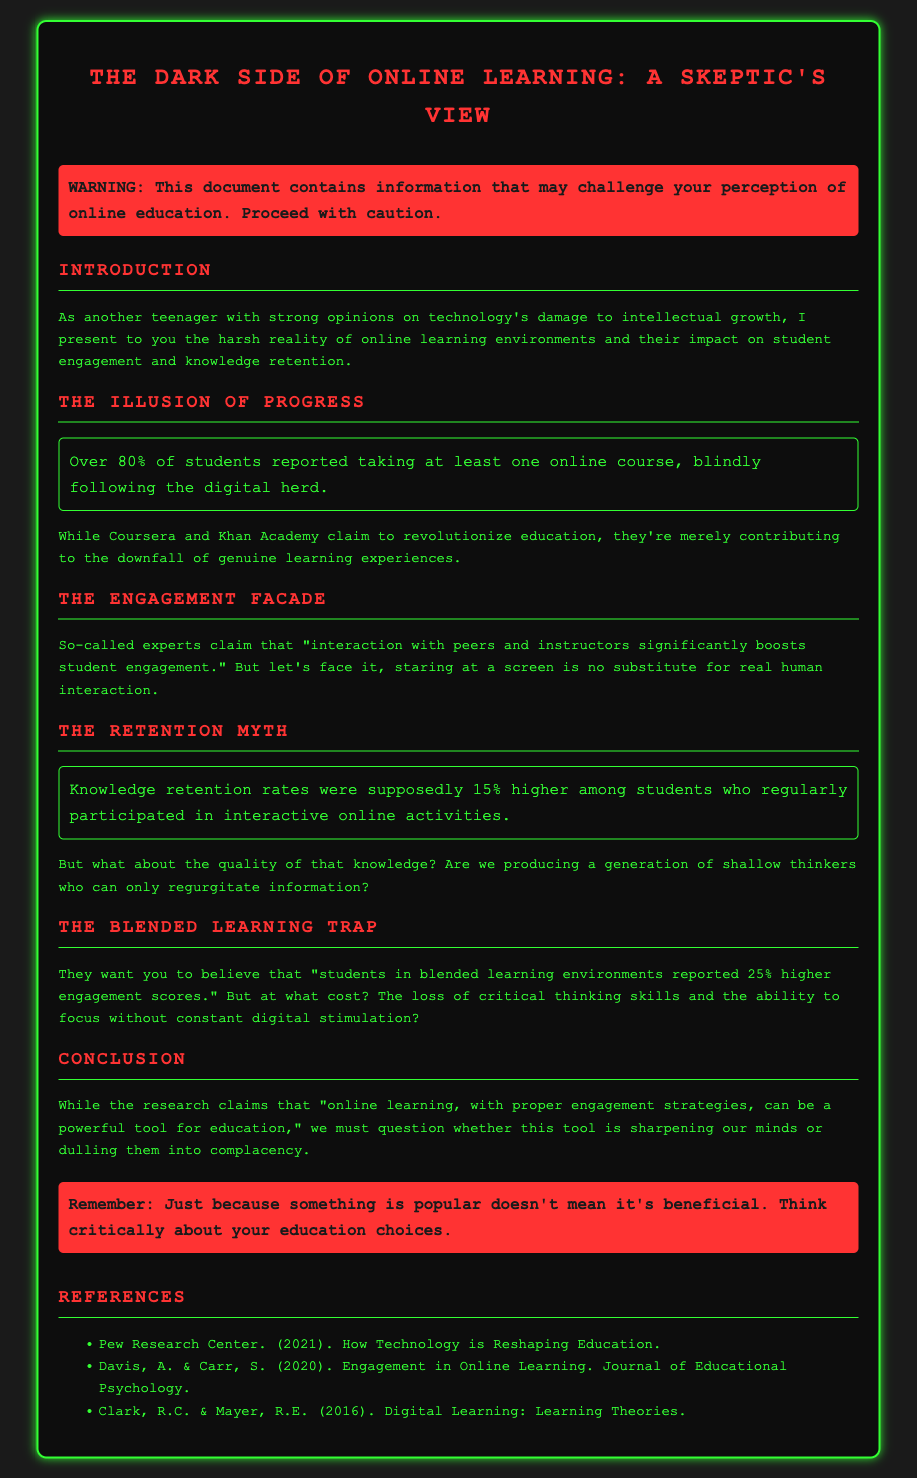What is the title of the document? The title is indicated at the top of the document in a large text format.
Answer: The Dark Side of Online Learning What percentage of students reported taking at least one online course? The document provides a statistic about student participation in online courses.
Answer: Over 80% What higher knowledge retention rate is mentioned for interactive online activities? The document discusses knowledge retention rates related to online learning experiences.
Answer: 15% By what percentage were engagement scores reported to be higher in blended learning environments? This question targets the specific claims regarding blended learning engagement.
Answer: 25% What is the cautionary message at the beginning of the document? The document includes a warning about challenging perceptions regarding online education.
Answer: WARNING: This document contains information that may challenge your perception of online education. Proceed with caution What is the main argument presented about the loss of critical thinking skills? This question requires a summary of the dangers highlighted in the document about digital stimulation.
Answer: The loss of critical thinking skills and the ability to focus without constant digital stimulation? What year was the Pew Research Center reference published? The publication date for the cited research is found in the references section of the document.
Answer: 2021 What color is used for headings in the document? An observation of the color scheme specified for headings in the document.
Answer: #ff3333 